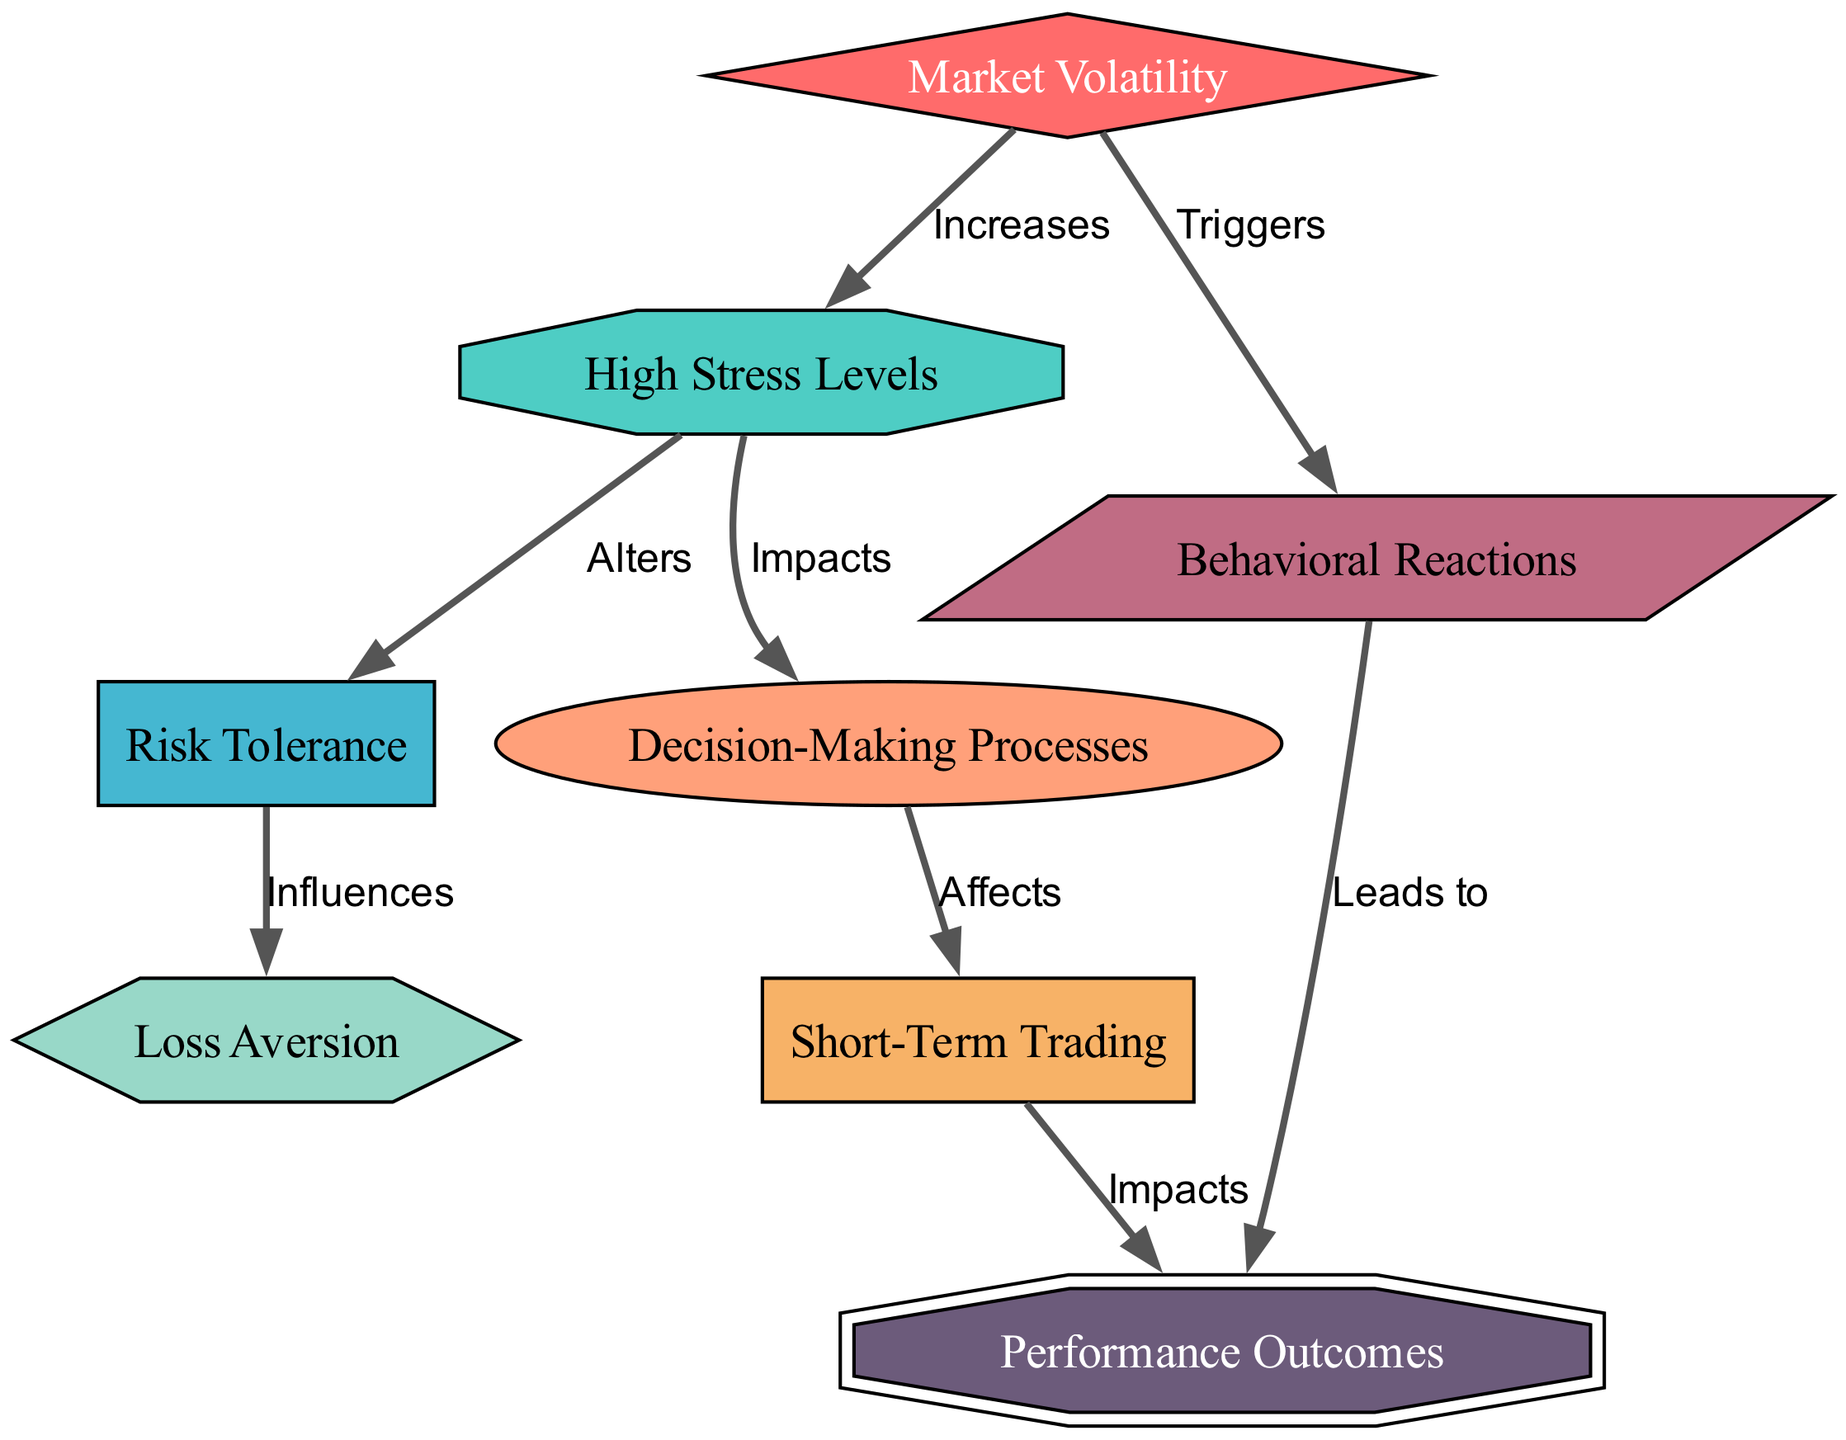What is the label of the node representing rapid changes in stock prices? The node that represents rapid changes in stock prices is labeled "Market Volatility". This is derived from the node identifiers in the diagram.
Answer: Market Volatility How many nodes are there in the diagram? By counting each unique node listed in the diagram data, there are a total of 8 nodes present.
Answer: 8 What types of reactions can be triggered by market volatility? According to the diagram, market volatility triggers "Behavioral Reactions". This relationship is noted in the edge connecting "Market Volatility" to "Behavioral Reactions".
Answer: Behavioral Reactions Which node has a relationship that indicates it impacts decision-making processes? The "Stress Levels" node is indicated as having an impact on the "Decision-Making Processes" node, as shown in the directed edge connecting them.
Answer: Stress Levels What is the relationship between risk tolerance and loss aversion? The diagram shows that "Risk Tolerance" influences "Loss Aversion". This means changes in risk tolerance will affect how losses are perceived and reacted to.
Answer: Influences How does high stress level alter risk tolerance? High stress levels lead to adjustments in risk tolerance, which is explicitly stated in the relationship between the "Stress Levels" and "Risk Tolerance" nodes.
Answer: Alters What effect do behavioral reactions have on performance outcomes? "Behavioral Reactions" lead to "Performance Outcomes" as represented by the directed edge connecting these two concepts in the diagram.
Answer: Leads to What is the main focus of the short-term trading node? The "Short-Term Trading" node focuses on quick trades aiming to exploit market fluctuations, as indicated in the label of the node itself.
Answer: Quick trades aiming to exploit market fluctuations What is the primary effect of market volatility on trader psychology? The primary effect of market volatility on trader psychology is that it increases "High Stress Levels". This is demonstrated through the directed edge leading from "Market Volatility" to "High Stress Levels".
Answer: Increases 